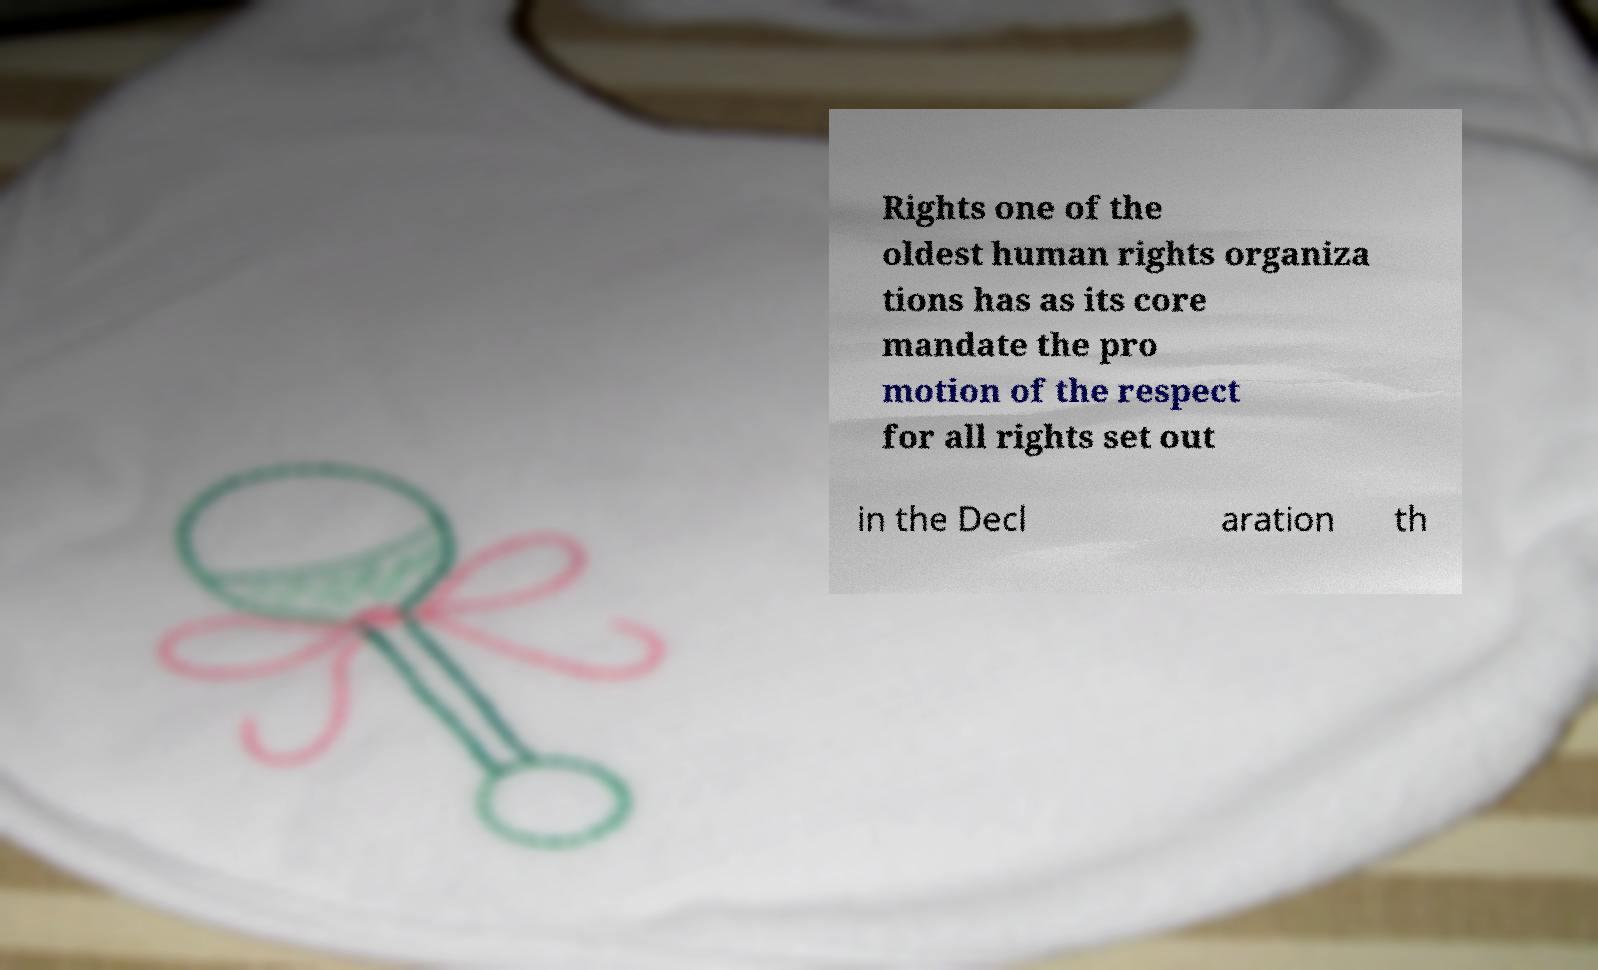I need the written content from this picture converted into text. Can you do that? Rights one of the oldest human rights organiza tions has as its core mandate the pro motion of the respect for all rights set out in the Decl aration th 